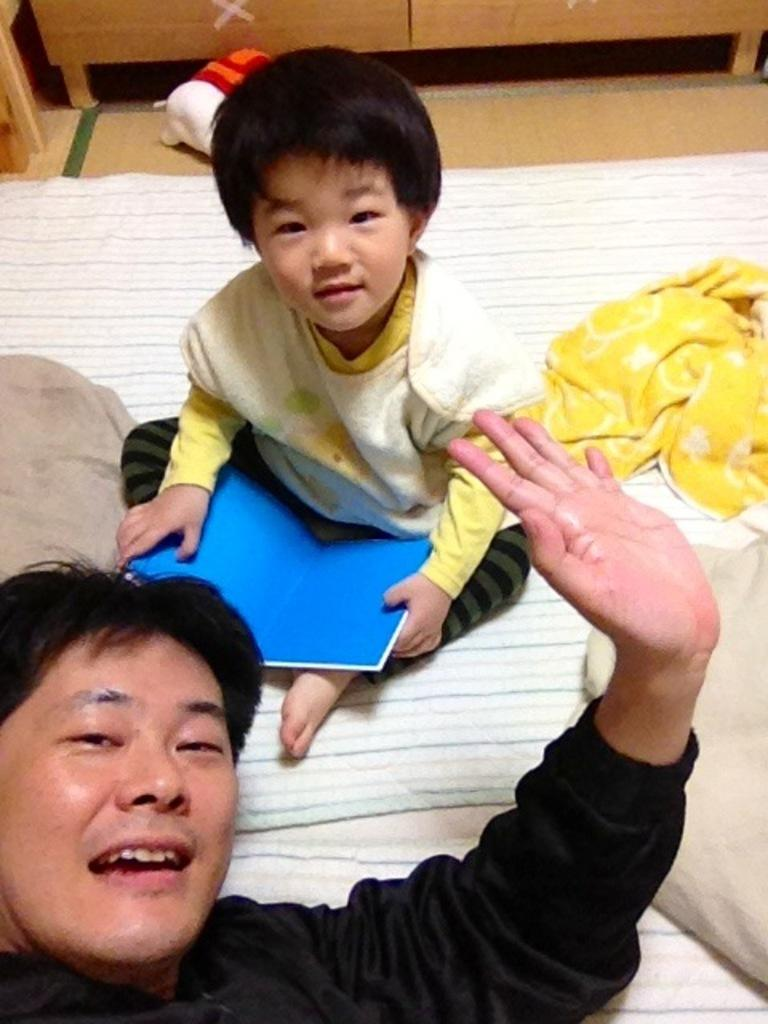What is the person wearing in the image? The person is wearing a black t-shirt in the image. What is the child doing in the image? The child is sitting in the image. What is the child holding in the image? The child is holding a blue book in the image. What other object can be seen in the image? There is a soft toy in the image. What type of furniture is present in the image? There are pillows in the image. What type of machine is being used by the person to give the child a haircut in the image? There is no machine or haircut being performed in the image; the person is simply wearing a black t-shirt and the child is holding a blue book. 